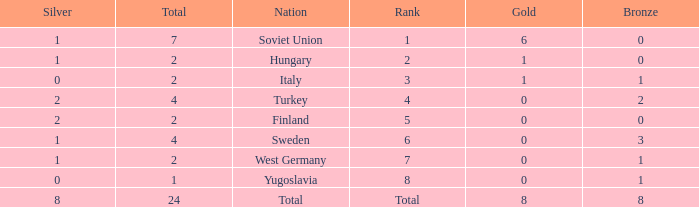What is the average Bronze, when Total is 7, and when Silver is greater than 1? None. 